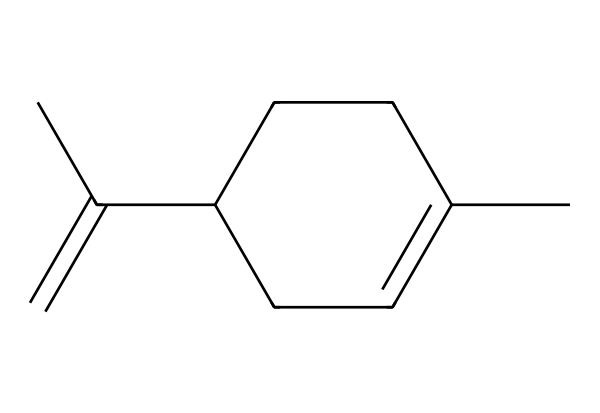What is the chemical name of the compound represented by this SMILES? The SMILES provided corresponds to a compound with the structure that visually represents a bicyclic molecule typical of terpenes. The common name derived from this structure with a citrus scent is limonene.
Answer: limonene How many carbon atoms are present in this molecule? By analyzing the SMILES representation, we can count the "C" characters. In this case, there are 10 carbon atoms in total.
Answer: 10 What type of chemical structure is this compound classified as? This compound has a structural formula featuring a bicyclic arrangement typical for terpenes and specifically, it is classified as a monoterpene due to containing 10 carbon atoms and being derived from essential oils.
Answer: monoterpene Does this compound contain any double bonds? Examining the structure indicated by the SMILES, we observe the presence of carbon-carbon double bonds (indicated by "C(=C)"). This confirms that yes, the compound does have double bonds.
Answer: yes What characteristic odor is associated with limonene? Limonene is well-known for its strong citrus scent commonly found in oranges and lemons. This characteristic odor can be traced back to the molecular structure that includes functional groups contributing to its fragrant properties.
Answer: citrus Is this compound polar or non-polar? Based on the molecular structure, the overall configuration of carbon and hydrogen atoms suggests that limonene is predominantly non-polar, as it lacks significant electronegative atoms that would induce polarity.
Answer: non-polar How is limonene commonly used in everyday products? Limonene is widely used due to its citrus aroma and functional properties. It is frequently incorporated in air fresheners, cleaning products, and food flavoring, capitalizing on its pleasant scent.
Answer: flavoring and fragrance 